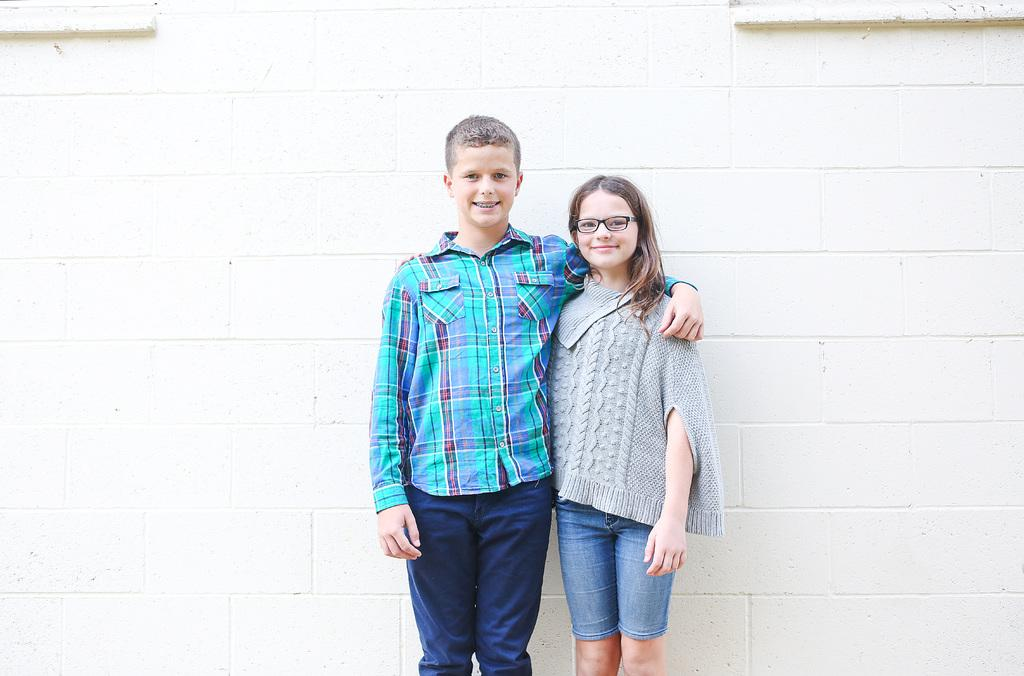Who are the subjects in the image? There is a boy and a girl in the image. What are the boy and girl doing in the image? Both the boy and girl are standing and smiling. What can be seen in the background of the image? There is a wall in the background of the image. What type of pig can be seen working alongside the laborer in the image? There is no pig or laborer present in the image; it features a boy and a girl standing and smiling. How deep is the hole that the girl is digging in the image? There is no hole present in the image; it features a boy and a girl standing and smiling. 